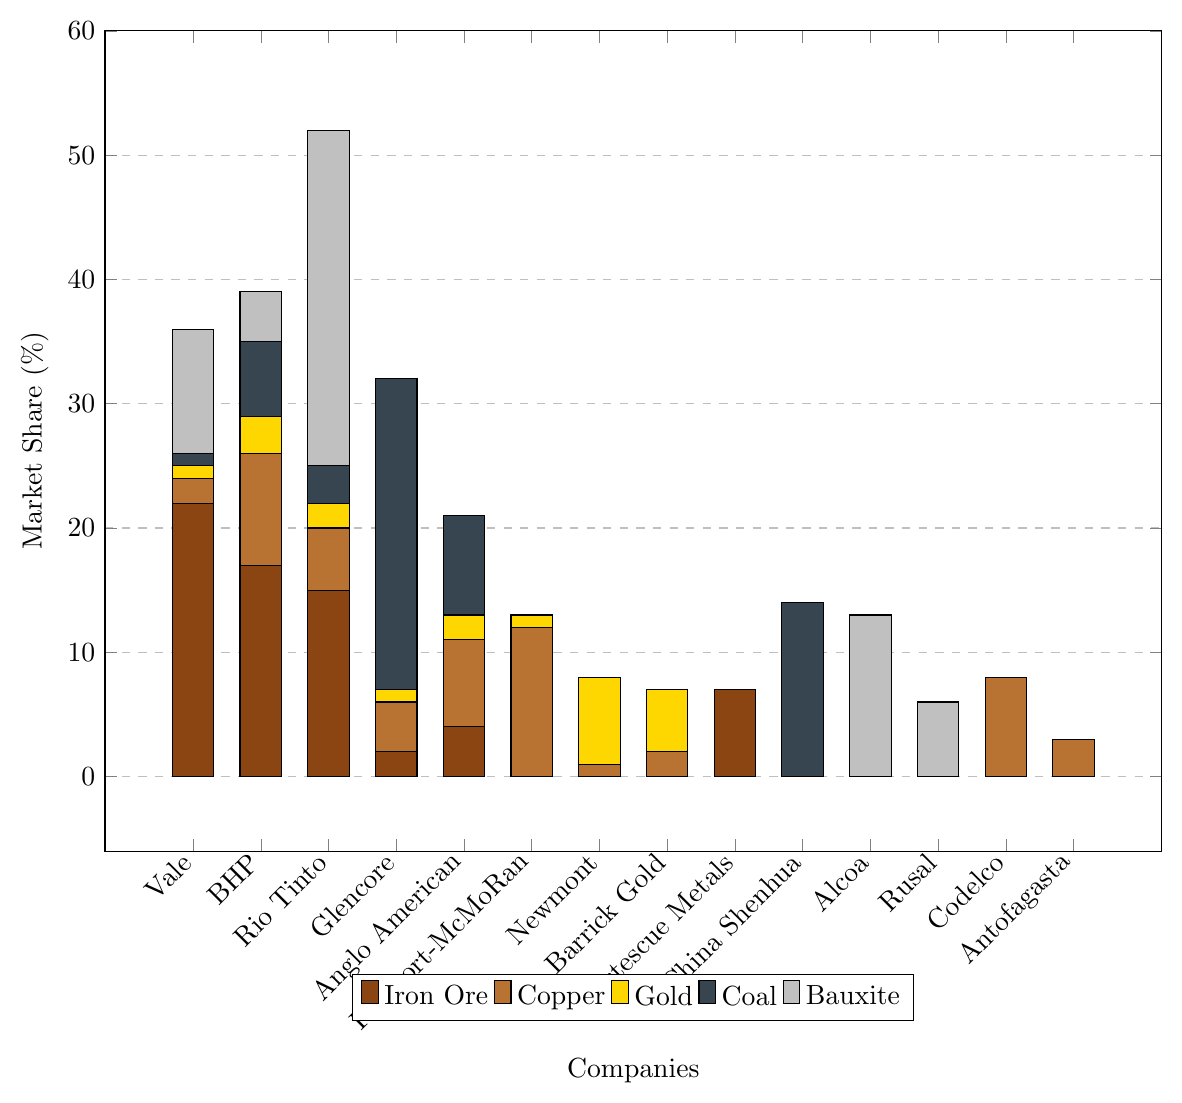Which company has the highest market share in the Iron Ore sector? Vale has the highest bar in the Iron Ore category, which indicates it has the largest market share at 22%.
Answer: Vale Which two companies combined have the highest market share in the Copper sector? BHP and Freeport-McMoRan have the highest individual bars for Copper, at 9% and 12% respectively, so their combined share is 21%.
Answer: BHP and Freeport-McMoRan What is the combined market share of Vale in all sectors? Sum the percentages for Vale: Iron Ore (22%) + Copper (2%) + Gold (1%) + Coal (1%) + Bauxite (10%) = 36%.
Answer: 36% Which company leads in the Bauxite sector by a large margin? Rio Tinto's bar is much higher than any other in the Bauxite sector, indicating it leads with 27%.
Answer: Rio Tinto Compare the market share of China Shenhua in the Coal sector to Rio Tinto in the same sector. Which is larger and by how much? China Shenhua has a market share of 14% in the Coal sector, while Rio Tinto has 3%. The difference is 14% - 3% = 11%.
Answer: China Shenhua by 11% Identify the sector in which Glencore has its largest market share, and specify the percentage. The tallest bar for Glencore is in the Coal sector, with a market share of 25%.
Answer: Coal, 25% Which of the companies have no market share in Gold? Fortescue Metals, China Shenhua, Alcoa, Rusal, Codelco, and Antofagasta have 0% market share in Gold.
Answer: Fortescue Metals, China Shenhua, Alcoa, Rusal, Codelco, Antofagasta In which sector does BHP have its highest market share? The highest bar for BHP is in the Iron Ore sector with a market share of 17%.
Answer: Iron Ore Calculate the difference in market share between Alcoa and Rusal in the Bauxite sector. Alcoa has a 13% market share in Bauxite, and Rusal has 6%. The difference is 13% - 6% = 7%.
Answer: 7% How many companies have a market share in the Coal sector? By counting the companies with non-zero values in the Coal category: BHP, Rio Tinto, Glencore, Anglo American, and China Shenhua, there are 5 companies.
Answer: 5 